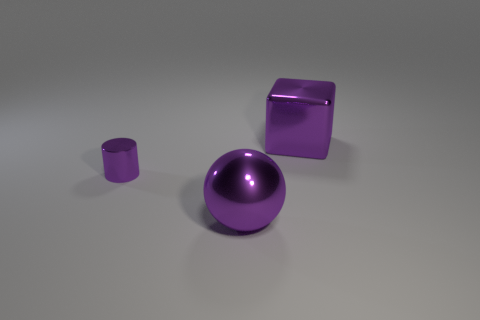Add 3 brown metallic spheres. How many objects exist? 6 Subtract all balls. How many objects are left? 2 Add 3 large red shiny spheres. How many large red shiny spheres exist? 3 Subtract 1 purple cylinders. How many objects are left? 2 Subtract all tiny gray things. Subtract all metallic things. How many objects are left? 0 Add 2 big metallic things. How many big metallic things are left? 4 